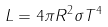<formula> <loc_0><loc_0><loc_500><loc_500>L = 4 \pi R ^ { 2 } \sigma T ^ { 4 }</formula> 